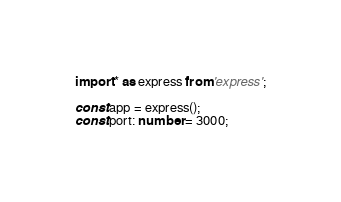Convert code to text. <code><loc_0><loc_0><loc_500><loc_500><_TypeScript_>import * as express from 'express';

const app = express();
const port: number = 3000;
</code> 